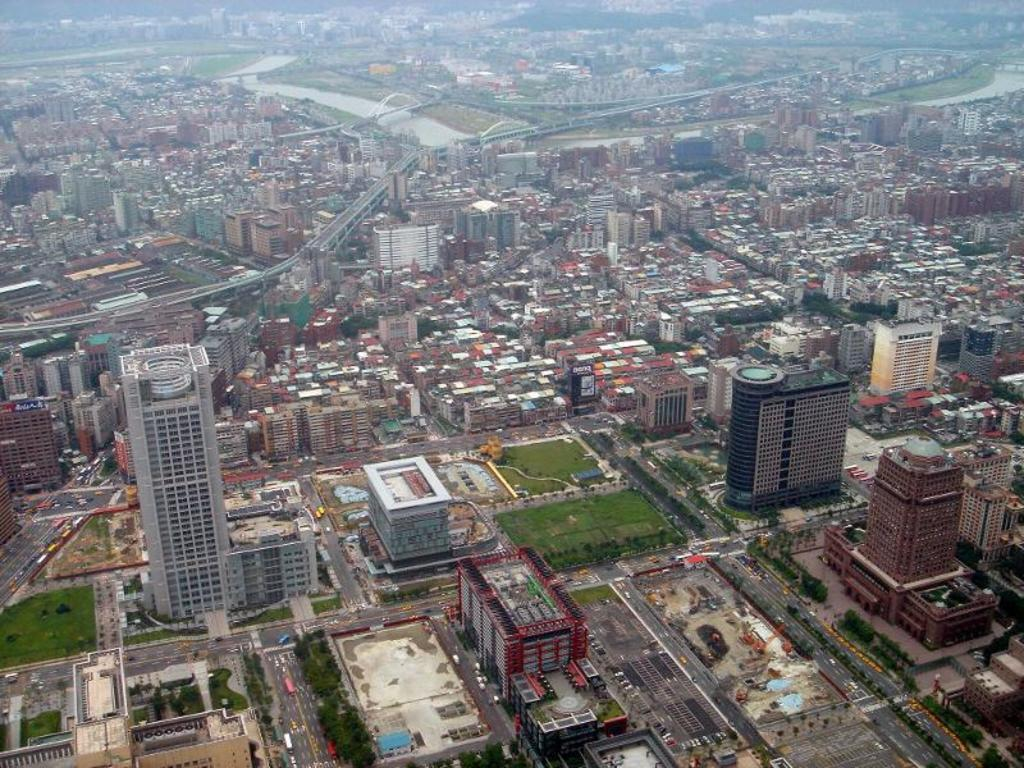What type of view is shown in the image? The image is an aerial view. What type of structures can be seen in the image? There are tower buildings in the image. What type of infrastructure is visible in the image? There are roads and bridges in the image. What type of natural elements can be seen in the image? There is grass and water visible in the image. Can you tell me how many horses are swimming in the water in the image? There are no horses visible in the image, and no horses are swimming in the water. 